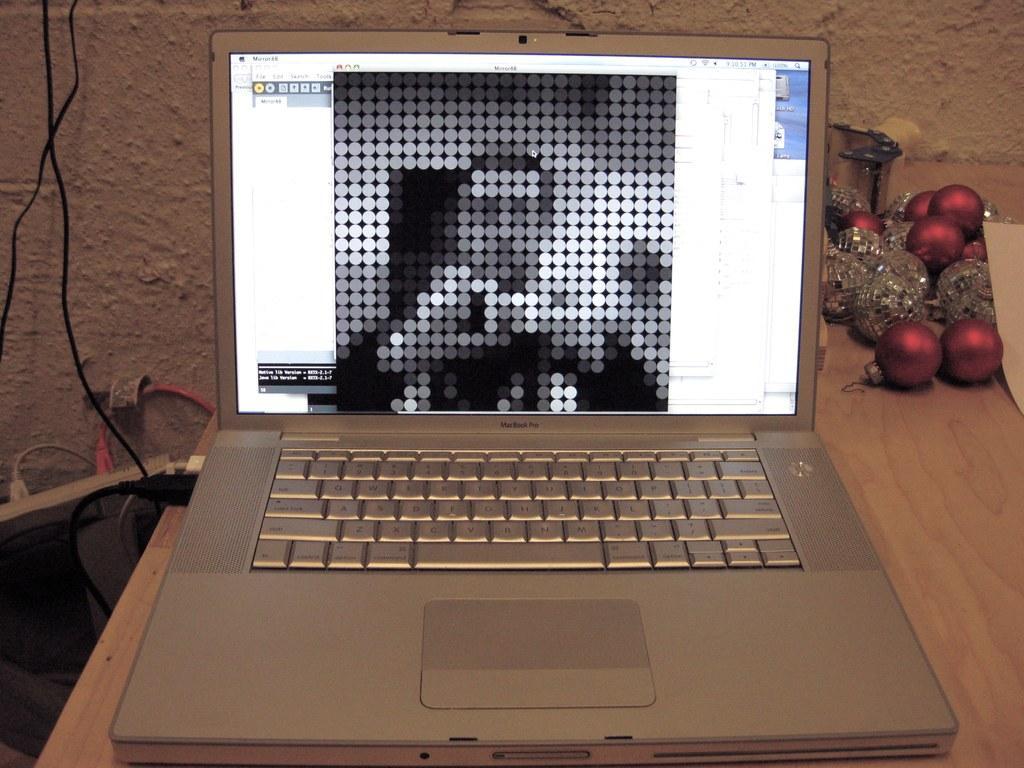Could you give a brief overview of what you see in this image? In this picture does a laptop kept on a table and data cable connected to it in the backdrop there is a wall 